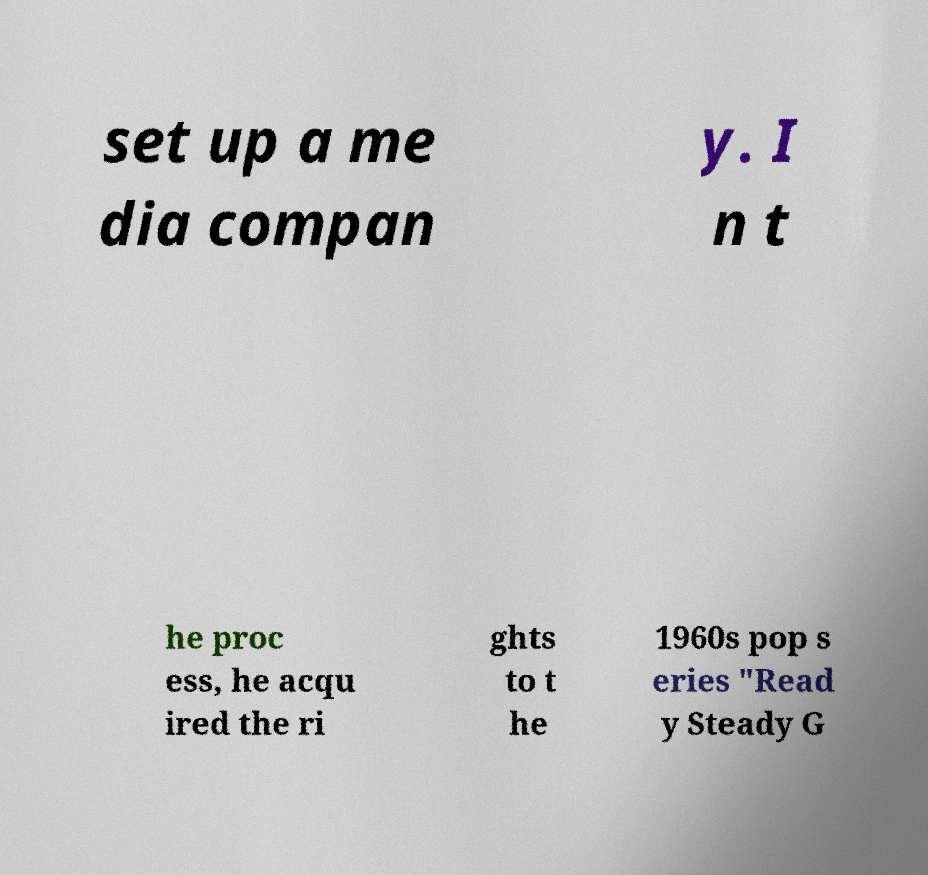Please read and relay the text visible in this image. What does it say? set up a me dia compan y. I n t he proc ess, he acqu ired the ri ghts to t he 1960s pop s eries "Read y Steady G 